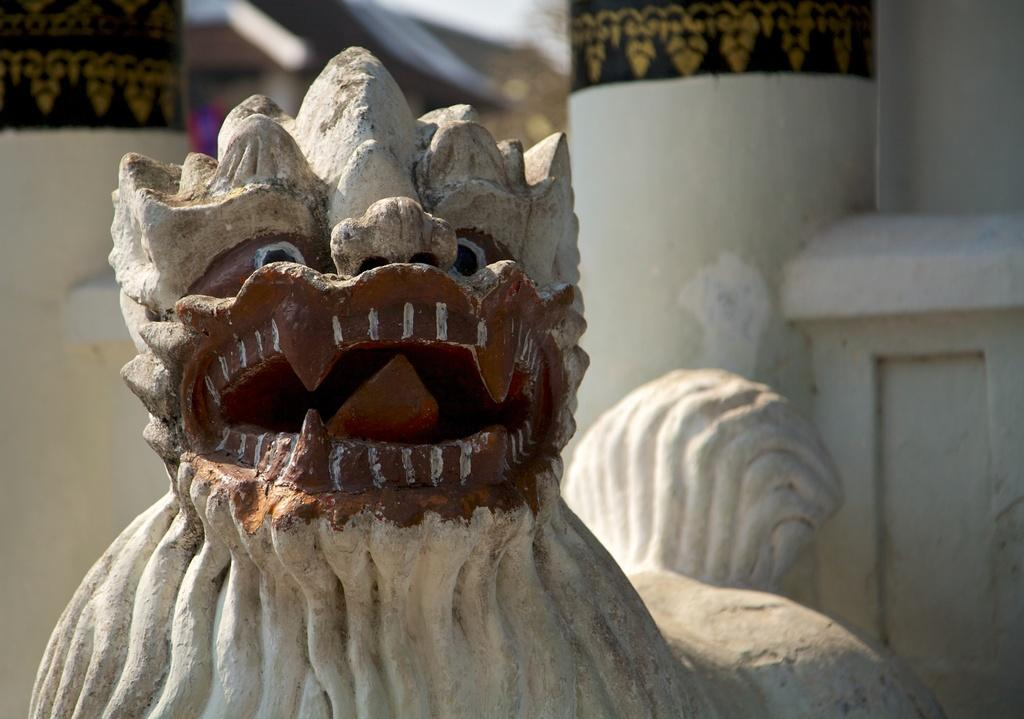What is the main subject in the center of the image? There is a sculpture in the center of the image. What can be seen in the background of the image? There is a wall visible in the background of the image. What type of locket is hanging from the elbow of the sculpture in the image? There is no locket or elbow present on the sculpture in the image. What is being served for dinner in the image? There is no dinner or any food-related items present in the image. 